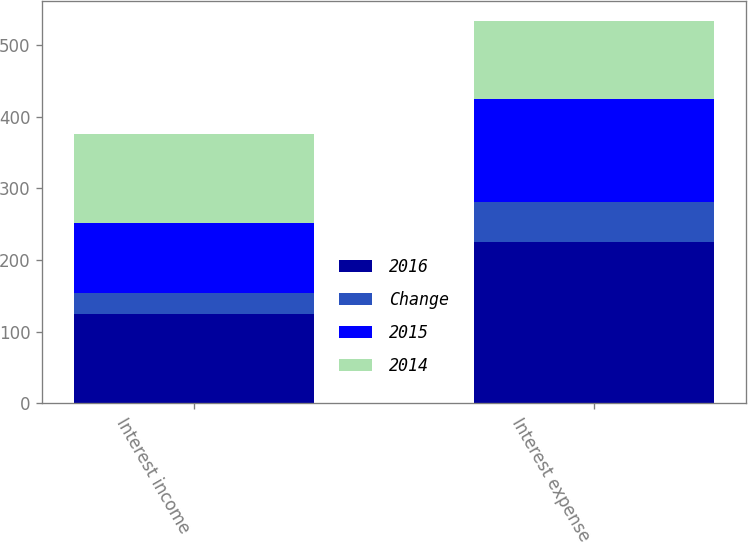<chart> <loc_0><loc_0><loc_500><loc_500><stacked_bar_chart><ecel><fcel>Interest income<fcel>Interest expense<nl><fcel>2016<fcel>125<fcel>225<nl><fcel>Change<fcel>29<fcel>56<nl><fcel>2015<fcel>97<fcel>144<nl><fcel>2014<fcel>125<fcel>109<nl></chart> 